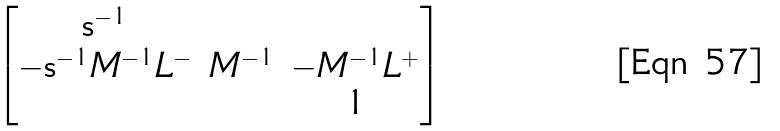<formula> <loc_0><loc_0><loc_500><loc_500>\begin{bmatrix} \mathsf s ^ { - 1 } & & \\ - \mathsf s ^ { - 1 } M ^ { - 1 } L ^ { - } & M ^ { - 1 } & - M ^ { - 1 } L ^ { + } \\ & & 1 \end{bmatrix}</formula> 